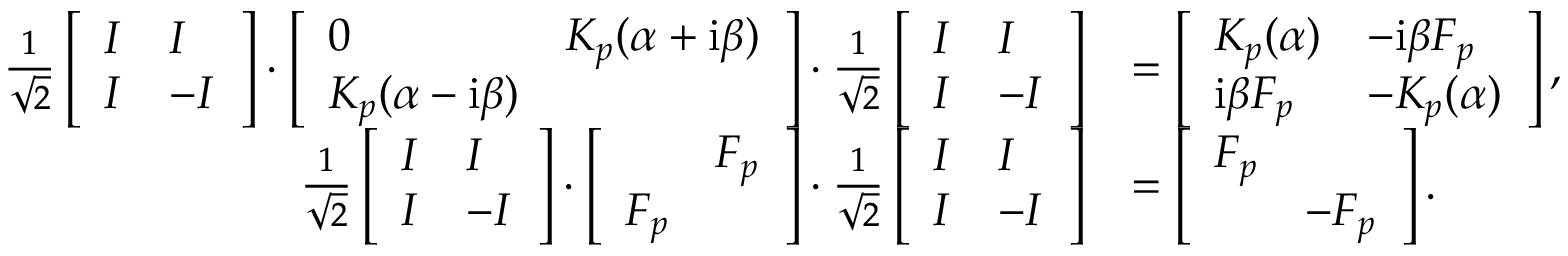Convert formula to latex. <formula><loc_0><loc_0><loc_500><loc_500>\begin{array} { r l } { \frac { 1 } { \sqrt { 2 } } \left [ \begin{array} { l l } { I } & { I } \\ { I } & { - I } \end{array} \right ] \cdot \left [ \begin{array} { l l } { 0 } & { K _ { p } ( \alpha + i \beta ) } \\ { K _ { p } ( \alpha - i \beta ) } & \end{array} \right ] \cdot \frac { 1 } { \sqrt { 2 } } \left [ \begin{array} { l l } { I } & { I } \\ { I } & { - I } \end{array} \right ] } & { = \left [ \begin{array} { l l } { K _ { p } ( \alpha ) } & { - i \beta F _ { p } } \\ { i \beta F _ { p } } & { - K _ { p } ( \alpha ) } \end{array} \right ] , } \\ { \frac { 1 } { \sqrt { 2 } } \left [ \begin{array} { l l } { I } & { I } \\ { I } & { - I } \end{array} \right ] \cdot \left [ \begin{array} { l l } & { F _ { p } } \\ { F _ { p } } & \end{array} \right ] \cdot \frac { 1 } { \sqrt { 2 } } \left [ \begin{array} { l l } { I } & { I } \\ { I } & { - I } \end{array} \right ] } & { = \left [ \begin{array} { l l } { F _ { p } } & \\ & { - F _ { p } } \end{array} \right ] . } \end{array}</formula> 